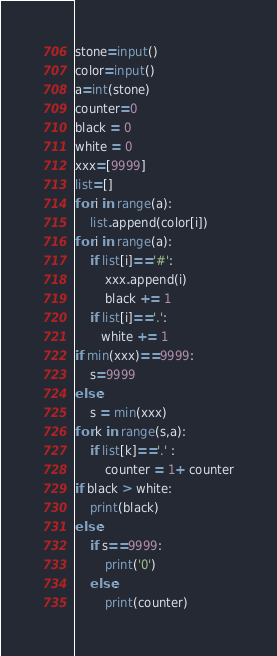<code> <loc_0><loc_0><loc_500><loc_500><_Python_>stone=input()
color=input()
a=int(stone)
counter=0
black = 0
white = 0
xxx=[9999]
list=[]
for i in range(a):
    list.append(color[i])
for i in range(a):
    if list[i]=='#':
        xxx.append(i)
        black += 1
    if list[i]=='.':
       white += 1
if min(xxx)==9999:
    s=9999
else:
    s = min(xxx)
for k in range(s,a):
    if list[k]=='.' :
        counter = 1+ counter
if black > white:
    print(black)
else:
    if s==9999:
        print('0')
    else:
        print(counter)</code> 